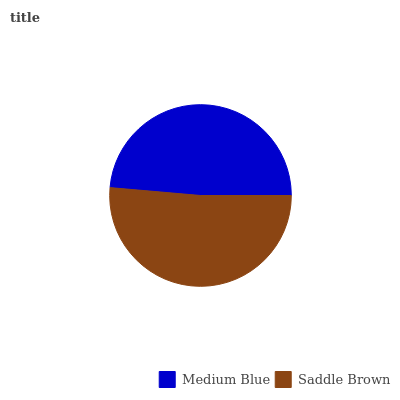Is Medium Blue the minimum?
Answer yes or no. Yes. Is Saddle Brown the maximum?
Answer yes or no. Yes. Is Saddle Brown the minimum?
Answer yes or no. No. Is Saddle Brown greater than Medium Blue?
Answer yes or no. Yes. Is Medium Blue less than Saddle Brown?
Answer yes or no. Yes. Is Medium Blue greater than Saddle Brown?
Answer yes or no. No. Is Saddle Brown less than Medium Blue?
Answer yes or no. No. Is Saddle Brown the high median?
Answer yes or no. Yes. Is Medium Blue the low median?
Answer yes or no. Yes. Is Medium Blue the high median?
Answer yes or no. No. Is Saddle Brown the low median?
Answer yes or no. No. 